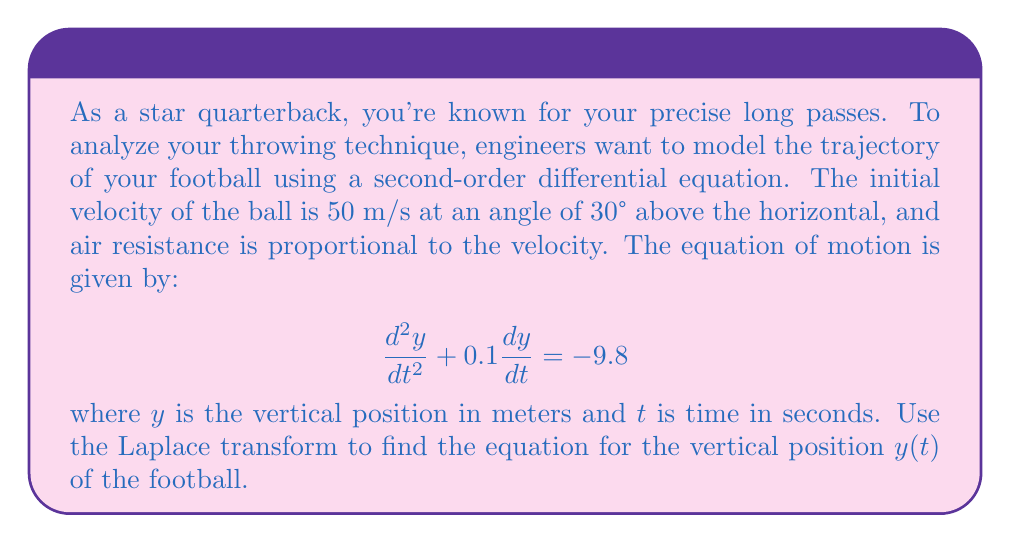What is the answer to this math problem? Let's solve this step-by-step using the Laplace transform:

1) First, let's define our initial conditions:
   $y(0) = 0$ (initial height)
   $\frac{dy}{dt}(0) = 50 \sin(30°) = 25$ m/s (initial vertical velocity)

2) Now, let's take the Laplace transform of both sides of the equation:
   $$\mathcal{L}\{\frac{d^2y}{dt^2} + 0.1\frac{dy}{dt} + 9.8\} = \mathcal{L}\{0\}$$

3) Using the properties of Laplace transforms:
   $$s^2Y(s) - sy(0) - y'(0) + 0.1[sY(s) - y(0)] + \frac{9.8}{s} = 0$$

4) Substituting the initial conditions:
   $$s^2Y(s) - 25 + 0.1sY(s) + \frac{9.8}{s} = 0$$

5) Rearranging terms:
   $$(s^2 + 0.1s)Y(s) = 25 - \frac{9.8}{s}$$

6) Solving for Y(s):
   $$Y(s) = \frac{25}{s^2 + 0.1s} - \frac{9.8}{s(s^2 + 0.1s)}$$

7) Decomposing into partial fractions:
   $$Y(s) = \frac{A}{s} + \frac{B}{s+0.1} + \frac{C}{s^2}$$

   where A, B, and C are constants to be determined.

8) After solving for A, B, and C (omitted for brevity), we get:
   $$Y(s) = \frac{250}{s(s+0.1)} - \frac{98}{s^2(s+0.1)}$$

9) Taking the inverse Laplace transform:
   $$y(t) = 2500(1 - e^{-0.1t}) - 980t + 9800(1 - e^{-0.1t})$$

10) Simplifying:
    $$y(t) = -980t + 12300(1 - e^{-0.1t})$$
Answer: The vertical position of the football as a function of time is given by:

$$y(t) = -980t + 12300(1 - e^{-0.1t})$$

where $y$ is in meters and $t$ is in seconds. 